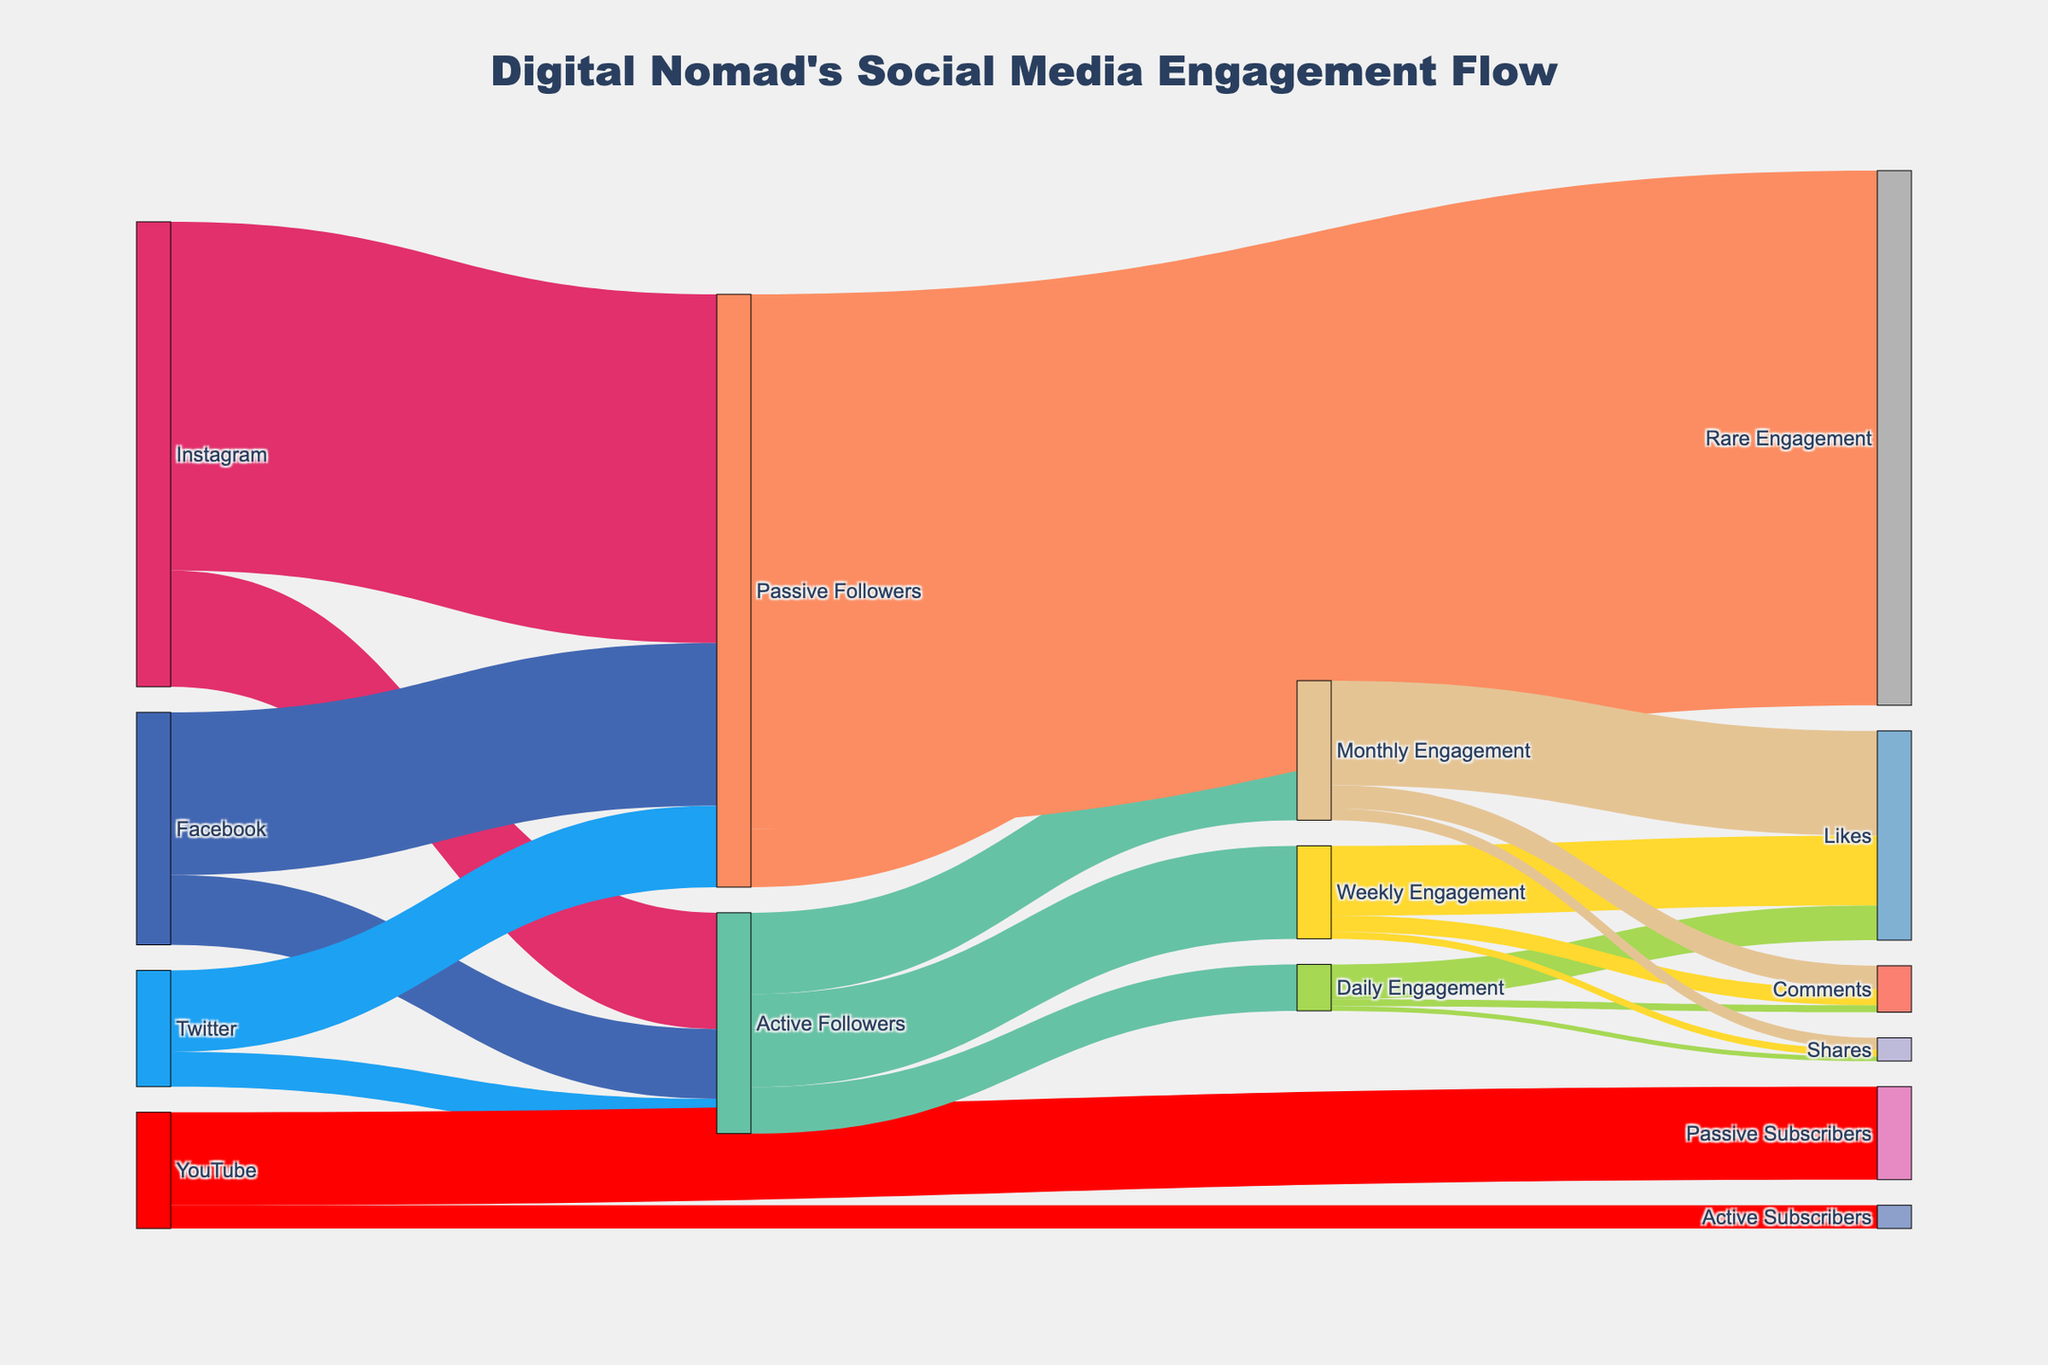How many active followers does Instagram have? The Sankey diagram shows that Instagram has 50,000 active followers flowing out from it.
Answer: 50,000 What is the total number of active followers across all social media platforms? The total number of active followers is the sum of active followers from Instagram, Facebook, Twitter, and active subscribers from YouTube. So, it's 50,000 (Instagram) + 30,000 (Facebook) + 15,000 (Twitter) + 10,000 (YouTube Active Subscribers) = 105,000.
Answer: 105,000 How does the number of passive followers on Facebook compare to that of Twitter? The Sankey diagram shows that Facebook has 70,000 passive followers, while Twitter has 35,000 passive followers. Facebook has twice the number of passive followers as Twitter.
Answer: Facebook has twice the number of passive followers as Twitter Which type of engagement has the highest number of interactions originating from active followers? The diagram shows that from active followers, monthly engagement has a total value of 35,000. This is compared to daily engagement with 20,000 and weekly engagement with 40,000. The highest is weekly engagement with 40,000.
Answer: Weekly engagement What is the total engagement from passive followers? The total engagement from passive followers is the sum of monthly engagement and rare engagement values. So, it's 25,000 (monthly engagement from passive) + 230,000 (rare engagement) = 255,000.
Answer: 255,000 How many likes are generated from weekly engagement? The sankey diagram shows that from weekly engagement, 30,000 are directed towards likes.
Answer: 30,000 Compare the comments generated from daily and monthly engagement. From daily engagement, 3,000 comments are generated. From monthly engagement, 10,000 comments are generated. Monthly engagement generates more comments than daily engagement.
Answer: Monthly engagement generates more comments than daily engagement What is the least frequent type of engagement among active followers? Among the engagement types from active followers, daily engagement has the lowest value at 20,000.
Answer: Daily engagement What fraction of passive followers engages monthly? There are 150,000 passive followers from Instagram, 70,000 from Facebook, and 35,000 from Twitter, totaling 255,000 passive followers. 25,000 of these engage monthly. Hence, the fraction is 25,000 / 255,000 = 1/10.2, approximately.
Answer: 1/10.2 Which social media platform has the highest number of active followers? The flow from Instagram shows it has 50,000 active followers, Facebook 30,000, Twitter 15,000, and YouTube 10,000 (active subscribers). Instagram has the highest number of active followers.
Answer: Instagram 